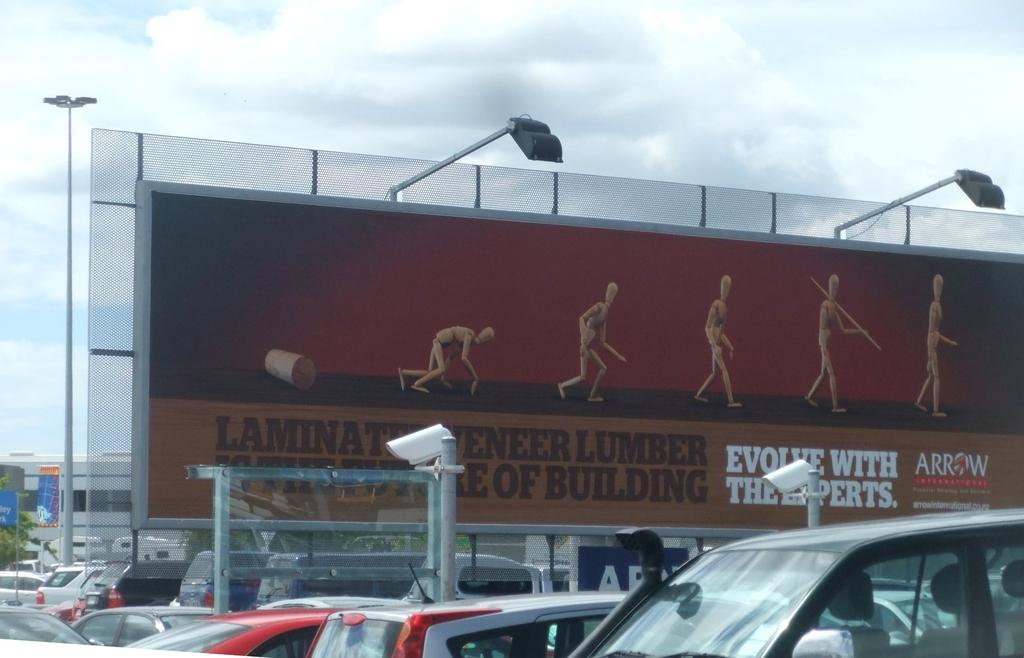Provide a one-sentence caption for the provided image. Banner with lumber for building and cars parked in a parking lot. 